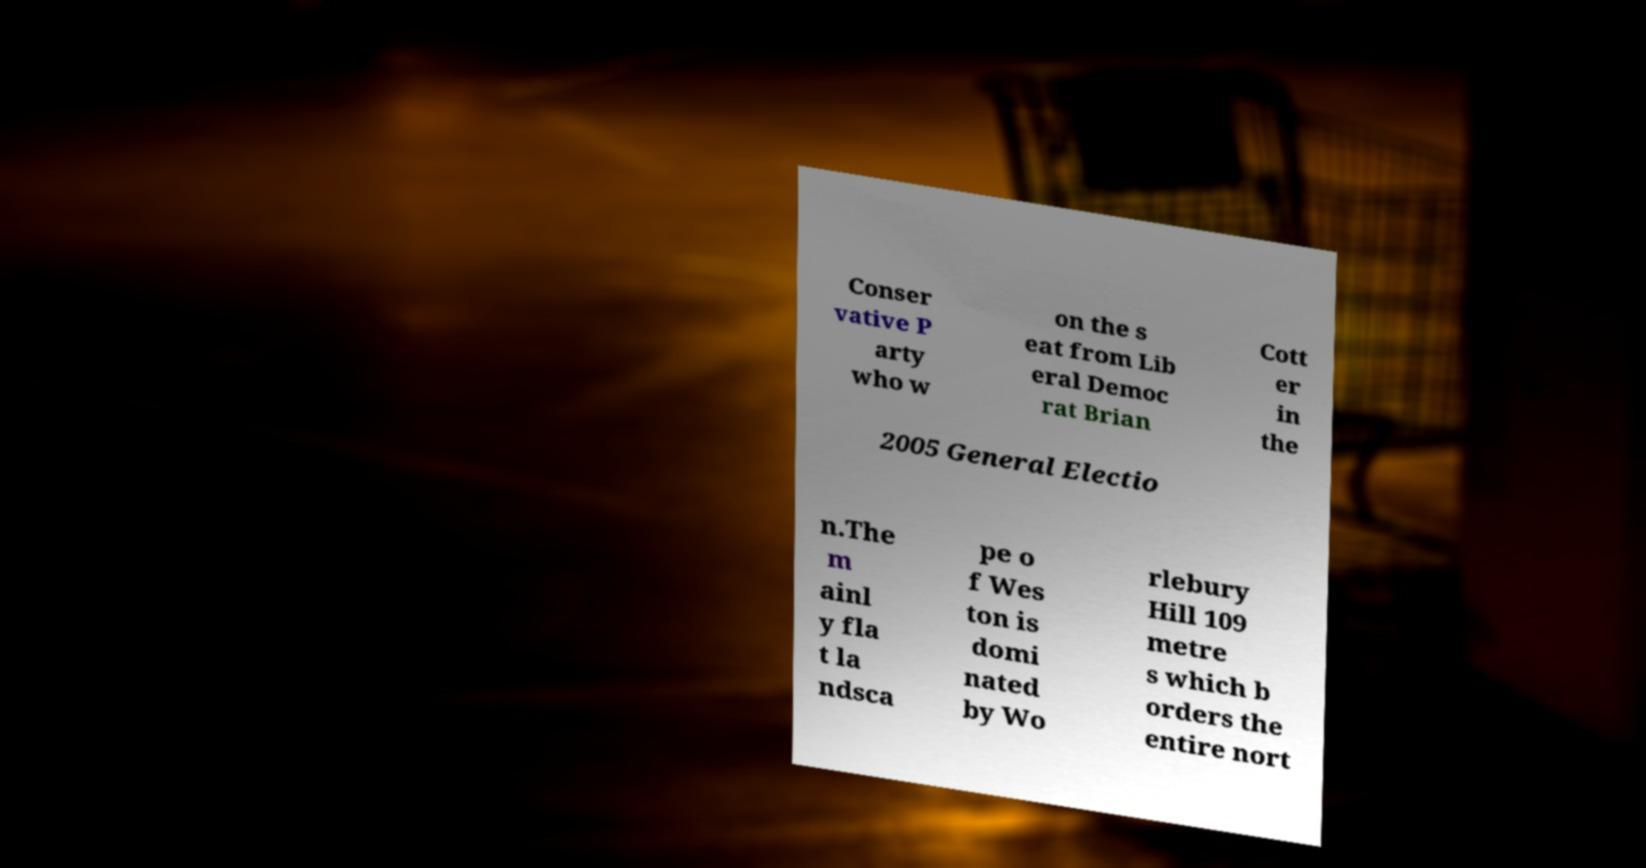Could you extract and type out the text from this image? Conser vative P arty who w on the s eat from Lib eral Democ rat Brian Cott er in the 2005 General Electio n.The m ainl y fla t la ndsca pe o f Wes ton is domi nated by Wo rlebury Hill 109 metre s which b orders the entire nort 